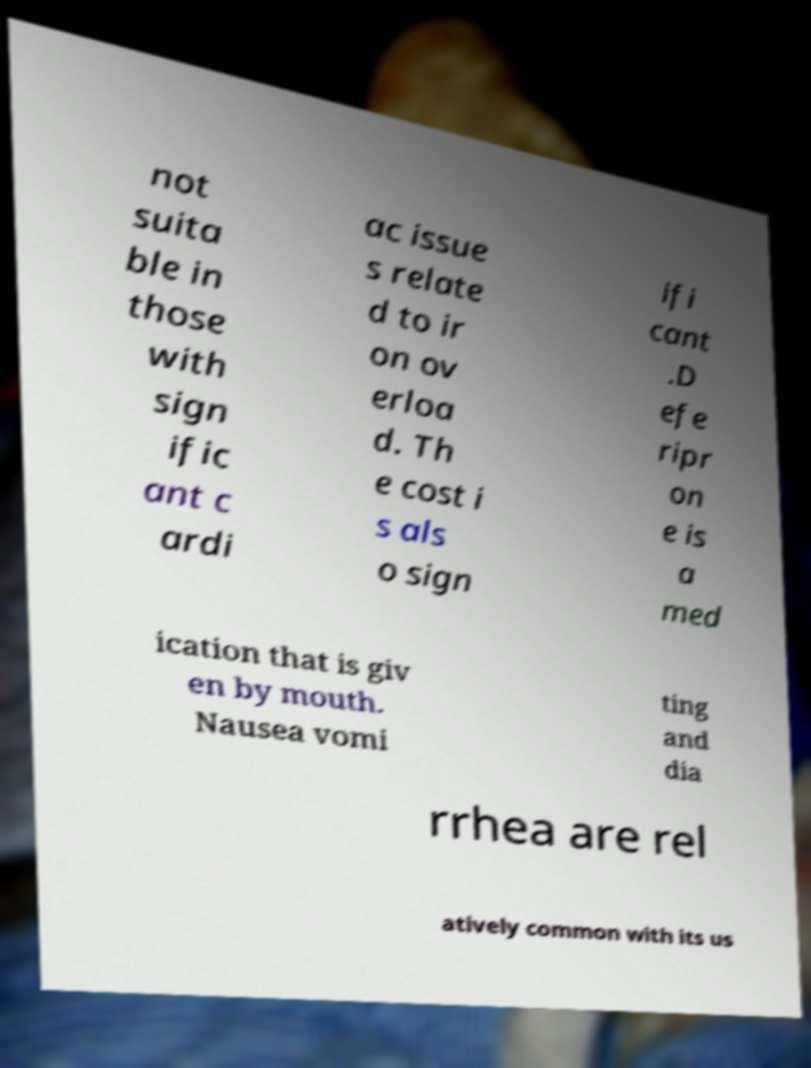I need the written content from this picture converted into text. Can you do that? not suita ble in those with sign ific ant c ardi ac issue s relate d to ir on ov erloa d. Th e cost i s als o sign ifi cant .D efe ripr on e is a med ication that is giv en by mouth. Nausea vomi ting and dia rrhea are rel atively common with its us 